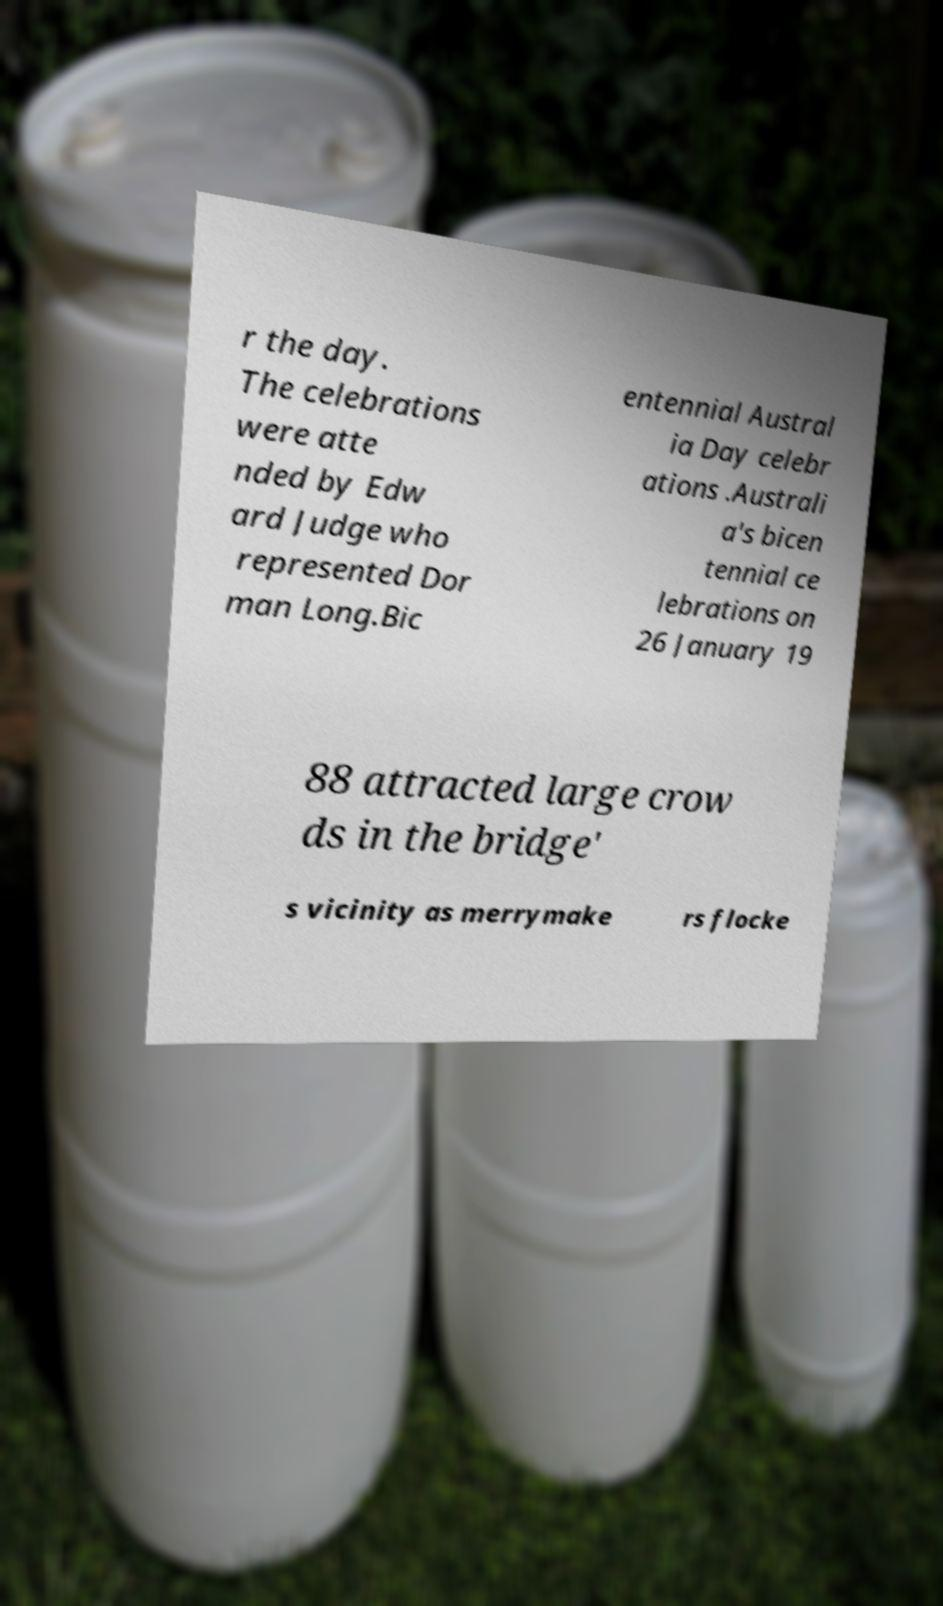What messages or text are displayed in this image? I need them in a readable, typed format. r the day. The celebrations were atte nded by Edw ard Judge who represented Dor man Long.Bic entennial Austral ia Day celebr ations .Australi a's bicen tennial ce lebrations on 26 January 19 88 attracted large crow ds in the bridge' s vicinity as merrymake rs flocke 